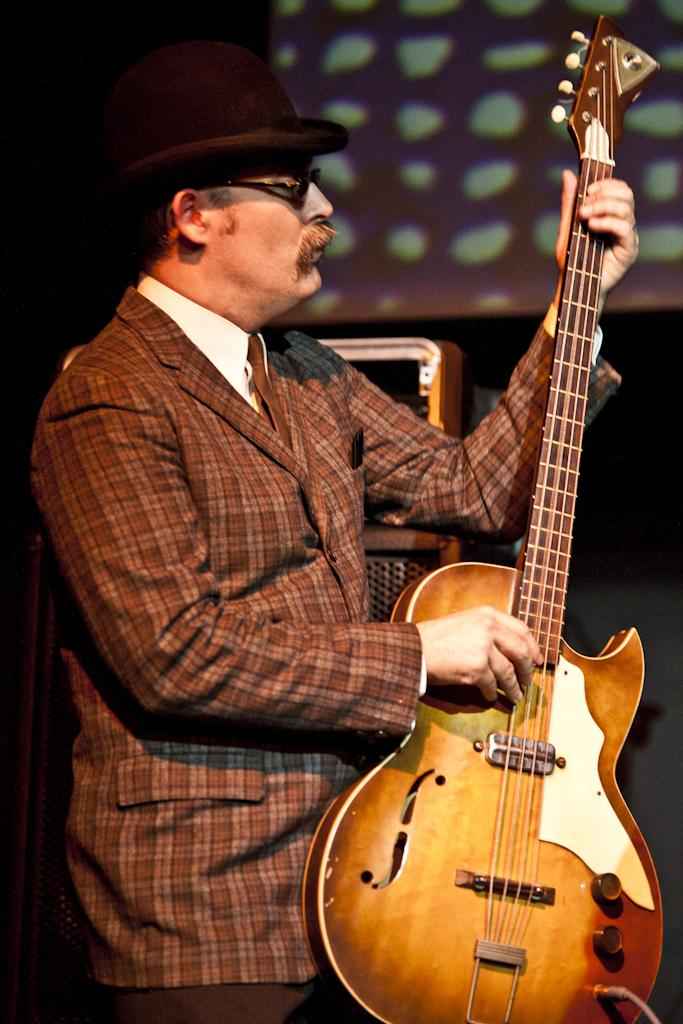What is the main subject of the image? The main subject of the image is a man. What is the man doing in the image? The man is standing in the image. What object is the man holding in the image? The man is holding a guitar in his hands. What type of clothing is the man wearing on his head? The man is wearing a hat in the image. What color is the coat the man is wearing? The man is wearing a brown coat in the image. What type of jeans is the man wearing in the image? There is no mention of jeans in the provided facts, so we cannot determine what type of jeans the man is wearing in the image. 